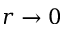<formula> <loc_0><loc_0><loc_500><loc_500>r \rightarrow 0</formula> 